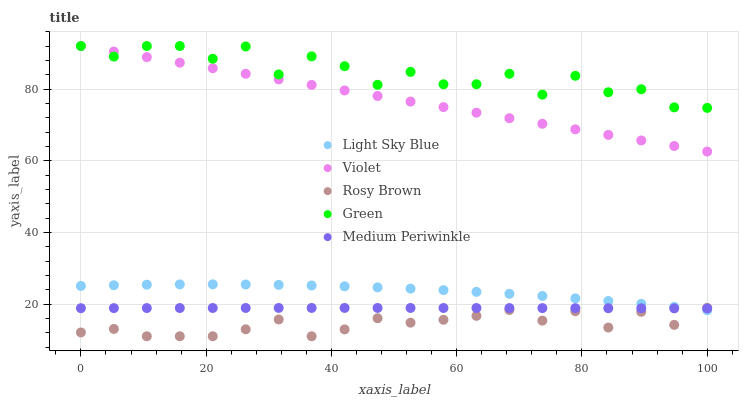Does Rosy Brown have the minimum area under the curve?
Answer yes or no. Yes. Does Green have the maximum area under the curve?
Answer yes or no. Yes. Does Light Sky Blue have the minimum area under the curve?
Answer yes or no. No. Does Light Sky Blue have the maximum area under the curve?
Answer yes or no. No. Is Violet the smoothest?
Answer yes or no. Yes. Is Green the roughest?
Answer yes or no. Yes. Is Rosy Brown the smoothest?
Answer yes or no. No. Is Rosy Brown the roughest?
Answer yes or no. No. Does Rosy Brown have the lowest value?
Answer yes or no. Yes. Does Light Sky Blue have the lowest value?
Answer yes or no. No. Does Violet have the highest value?
Answer yes or no. Yes. Does Rosy Brown have the highest value?
Answer yes or no. No. Is Medium Periwinkle less than Violet?
Answer yes or no. Yes. Is Violet greater than Rosy Brown?
Answer yes or no. Yes. Does Green intersect Violet?
Answer yes or no. Yes. Is Green less than Violet?
Answer yes or no. No. Is Green greater than Violet?
Answer yes or no. No. Does Medium Periwinkle intersect Violet?
Answer yes or no. No. 